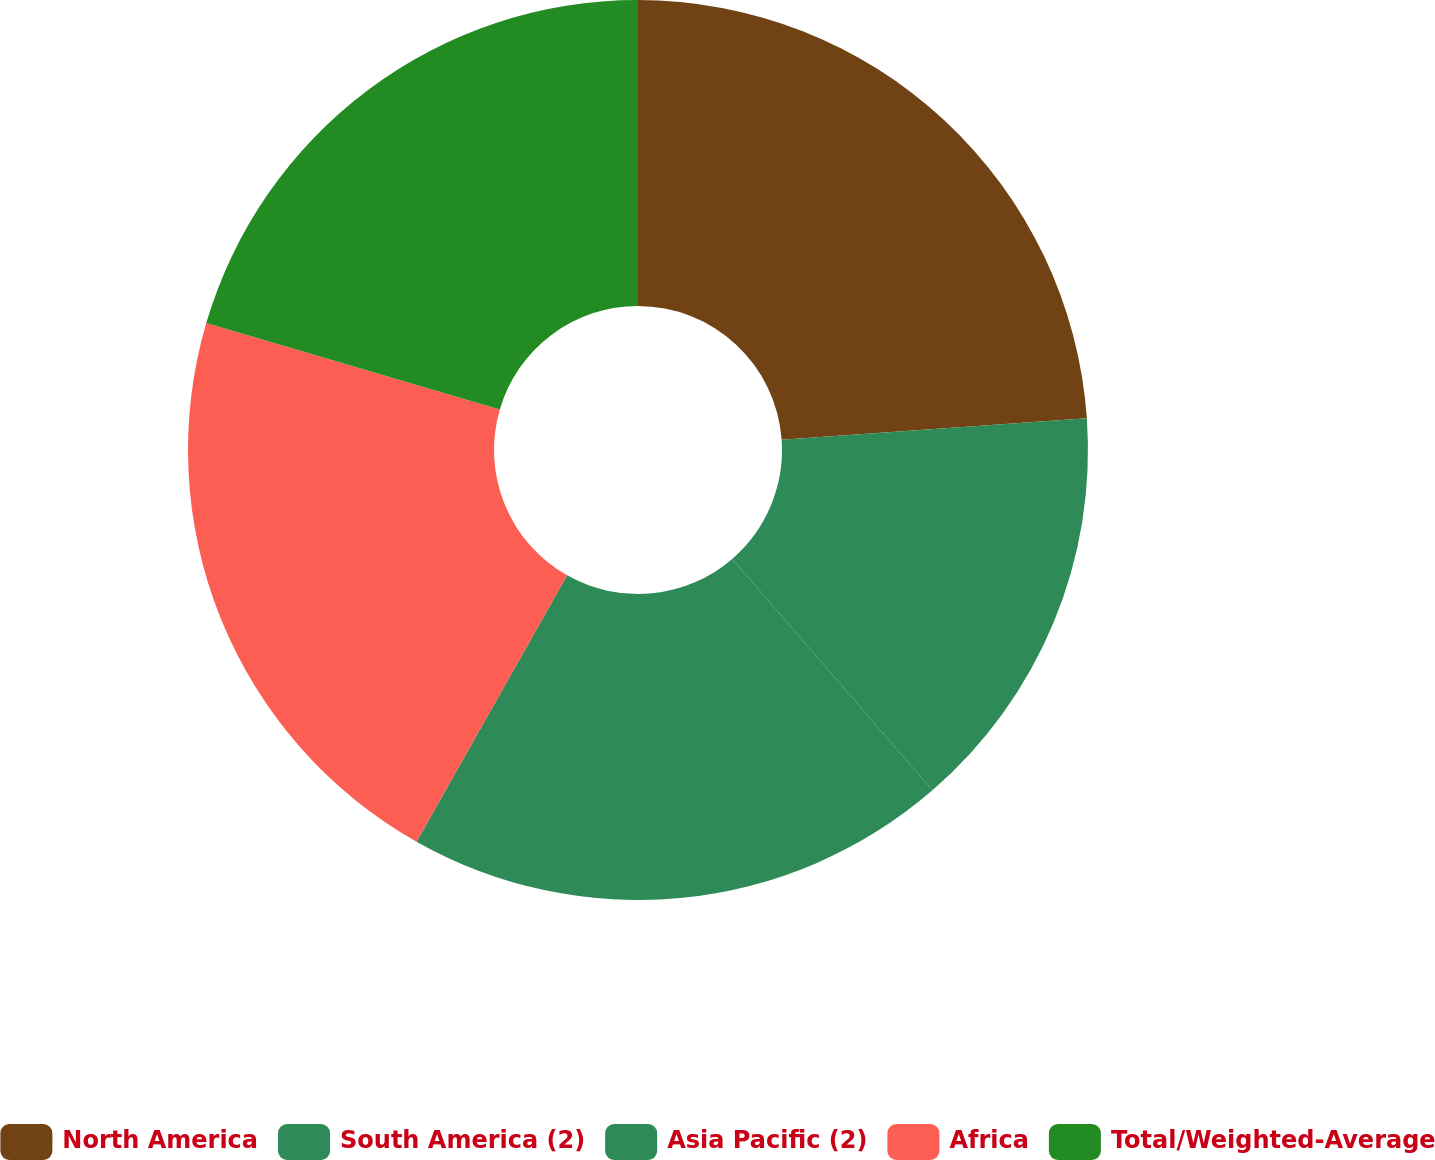Convert chart. <chart><loc_0><loc_0><loc_500><loc_500><pie_chart><fcel>North America<fcel>South America (2)<fcel>Asia Pacific (2)<fcel>Africa<fcel>Total/Weighted-Average<nl><fcel>23.88%<fcel>14.77%<fcel>19.54%<fcel>21.36%<fcel>20.45%<nl></chart> 